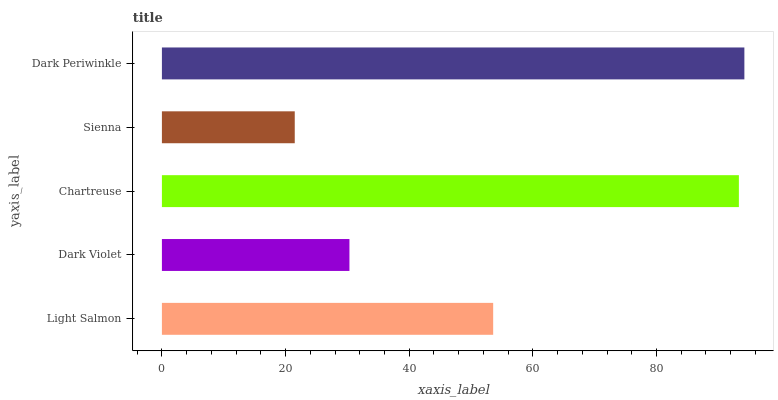Is Sienna the minimum?
Answer yes or no. Yes. Is Dark Periwinkle the maximum?
Answer yes or no. Yes. Is Dark Violet the minimum?
Answer yes or no. No. Is Dark Violet the maximum?
Answer yes or no. No. Is Light Salmon greater than Dark Violet?
Answer yes or no. Yes. Is Dark Violet less than Light Salmon?
Answer yes or no. Yes. Is Dark Violet greater than Light Salmon?
Answer yes or no. No. Is Light Salmon less than Dark Violet?
Answer yes or no. No. Is Light Salmon the high median?
Answer yes or no. Yes. Is Light Salmon the low median?
Answer yes or no. Yes. Is Dark Periwinkle the high median?
Answer yes or no. No. Is Chartreuse the low median?
Answer yes or no. No. 